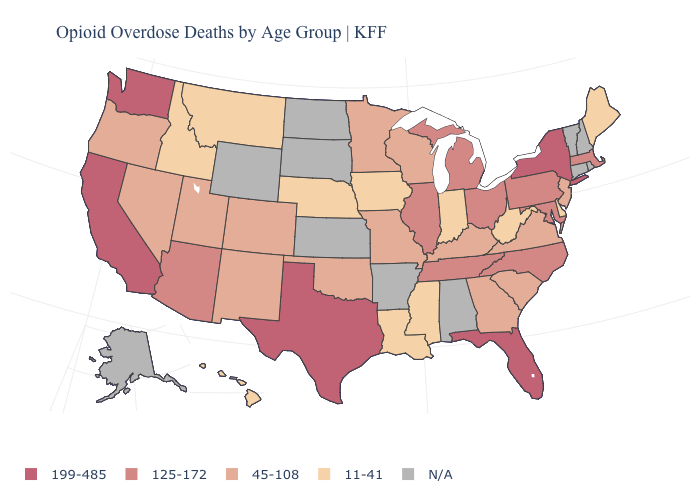How many symbols are there in the legend?
Answer briefly. 5. How many symbols are there in the legend?
Be succinct. 5. Which states have the highest value in the USA?
Keep it brief. California, Florida, New York, Texas, Washington. What is the value of Michigan?
Be succinct. 125-172. What is the value of Alaska?
Quick response, please. N/A. What is the value of Tennessee?
Keep it brief. 125-172. Which states have the lowest value in the USA?
Give a very brief answer. Delaware, Hawaii, Idaho, Indiana, Iowa, Louisiana, Maine, Mississippi, Montana, Nebraska, West Virginia. Name the states that have a value in the range 45-108?
Quick response, please. Colorado, Georgia, Kentucky, Minnesota, Missouri, Nevada, New Jersey, New Mexico, Oklahoma, Oregon, South Carolina, Utah, Virginia, Wisconsin. Name the states that have a value in the range 199-485?
Give a very brief answer. California, Florida, New York, Texas, Washington. What is the value of North Dakota?
Quick response, please. N/A. Name the states that have a value in the range 199-485?
Short answer required. California, Florida, New York, Texas, Washington. Among the states that border Wyoming , does Colorado have the highest value?
Write a very short answer. Yes. Among the states that border Tennessee , which have the highest value?
Short answer required. North Carolina. 